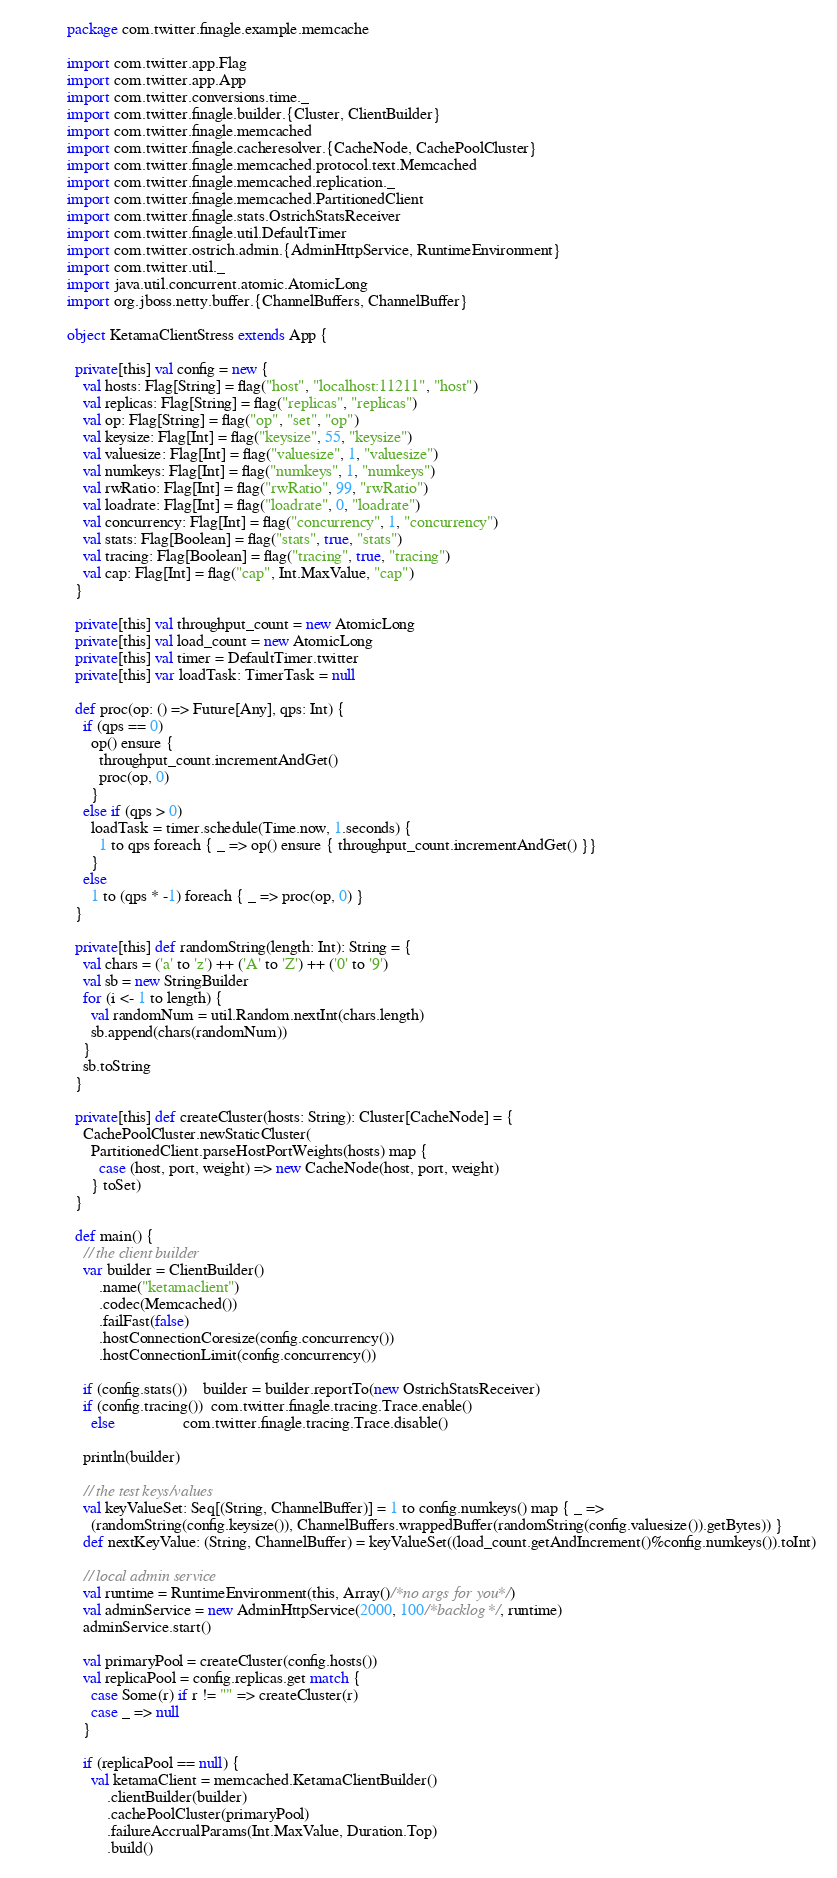Convert code to text. <code><loc_0><loc_0><loc_500><loc_500><_Scala_>package com.twitter.finagle.example.memcache

import com.twitter.app.Flag
import com.twitter.app.App
import com.twitter.conversions.time._
import com.twitter.finagle.builder.{Cluster, ClientBuilder}
import com.twitter.finagle.memcached
import com.twitter.finagle.cacheresolver.{CacheNode, CachePoolCluster}
import com.twitter.finagle.memcached.protocol.text.Memcached
import com.twitter.finagle.memcached.replication._
import com.twitter.finagle.memcached.PartitionedClient
import com.twitter.finagle.stats.OstrichStatsReceiver
import com.twitter.finagle.util.DefaultTimer
import com.twitter.ostrich.admin.{AdminHttpService, RuntimeEnvironment}
import com.twitter.util._
import java.util.concurrent.atomic.AtomicLong
import org.jboss.netty.buffer.{ChannelBuffers, ChannelBuffer}

object KetamaClientStress extends App {

  private[this] val config = new {
    val hosts: Flag[String] = flag("host", "localhost:11211", "host")
    val replicas: Flag[String] = flag("replicas", "replicas")
    val op: Flag[String] = flag("op", "set", "op")
    val keysize: Flag[Int] = flag("keysize", 55, "keysize")
    val valuesize: Flag[Int] = flag("valuesize", 1, "valuesize")
    val numkeys: Flag[Int] = flag("numkeys", 1, "numkeys")
    val rwRatio: Flag[Int] = flag("rwRatio", 99, "rwRatio")
    val loadrate: Flag[Int] = flag("loadrate", 0, "loadrate")
    val concurrency: Flag[Int] = flag("concurrency", 1, "concurrency")
    val stats: Flag[Boolean] = flag("stats", true, "stats")
    val tracing: Flag[Boolean] = flag("tracing", true, "tracing")
    val cap: Flag[Int] = flag("cap", Int.MaxValue, "cap")
  }

  private[this] val throughput_count = new AtomicLong
  private[this] val load_count = new AtomicLong
  private[this] val timer = DefaultTimer.twitter
  private[this] var loadTask: TimerTask = null

  def proc(op: () => Future[Any], qps: Int) {
    if (qps == 0)
      op() ensure {
        throughput_count.incrementAndGet()
        proc(op, 0)
      }
    else if (qps > 0)
      loadTask = timer.schedule(Time.now, 1.seconds) {
        1 to qps foreach { _ => op() ensure { throughput_count.incrementAndGet() }}
      }
    else
      1 to (qps * -1) foreach { _ => proc(op, 0) }
  }

  private[this] def randomString(length: Int): String = {
    val chars = ('a' to 'z') ++ ('A' to 'Z') ++ ('0' to '9')
    val sb = new StringBuilder
    for (i <- 1 to length) {
      val randomNum = util.Random.nextInt(chars.length)
      sb.append(chars(randomNum))
    }
    sb.toString
  }

  private[this] def createCluster(hosts: String): Cluster[CacheNode] = {
    CachePoolCluster.newStaticCluster(
      PartitionedClient.parseHostPortWeights(hosts) map {
        case (host, port, weight) => new CacheNode(host, port, weight)
      } toSet)
  }

  def main() {
    // the client builder
    var builder = ClientBuilder()
        .name("ketamaclient")
        .codec(Memcached())
        .failFast(false)
        .hostConnectionCoresize(config.concurrency())
        .hostConnectionLimit(config.concurrency())

    if (config.stats())    builder = builder.reportTo(new OstrichStatsReceiver)
    if (config.tracing())  com.twitter.finagle.tracing.Trace.enable()
      else                 com.twitter.finagle.tracing.Trace.disable()

    println(builder)

    // the test keys/values
    val keyValueSet: Seq[(String, ChannelBuffer)] = 1 to config.numkeys() map { _ =>
      (randomString(config.keysize()), ChannelBuffers.wrappedBuffer(randomString(config.valuesize()).getBytes)) }
    def nextKeyValue: (String, ChannelBuffer) = keyValueSet((load_count.getAndIncrement()%config.numkeys()).toInt)

    // local admin service
    val runtime = RuntimeEnvironment(this, Array()/*no args for you*/)
    val adminService = new AdminHttpService(2000, 100/*backlog*/, runtime)
    adminService.start()

    val primaryPool = createCluster(config.hosts())
    val replicaPool = config.replicas.get match {
      case Some(r) if r != "" => createCluster(r)
      case _ => null
    }

    if (replicaPool == null) {
      val ketamaClient = memcached.KetamaClientBuilder()
          .clientBuilder(builder)
          .cachePoolCluster(primaryPool)
          .failureAccrualParams(Int.MaxValue, Duration.Top)
          .build()
</code> 